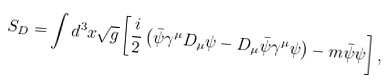<formula> <loc_0><loc_0><loc_500><loc_500>S _ { D } = \int d ^ { 3 } x \sqrt { g } \left [ \frac { i } { 2 } \left ( \bar { \psi } \gamma ^ { \mu } D _ { \mu } \psi - D _ { \mu } \bar { \psi } \gamma ^ { \mu } \psi \right ) - m \bar { \psi } \psi \right ] ,</formula> 